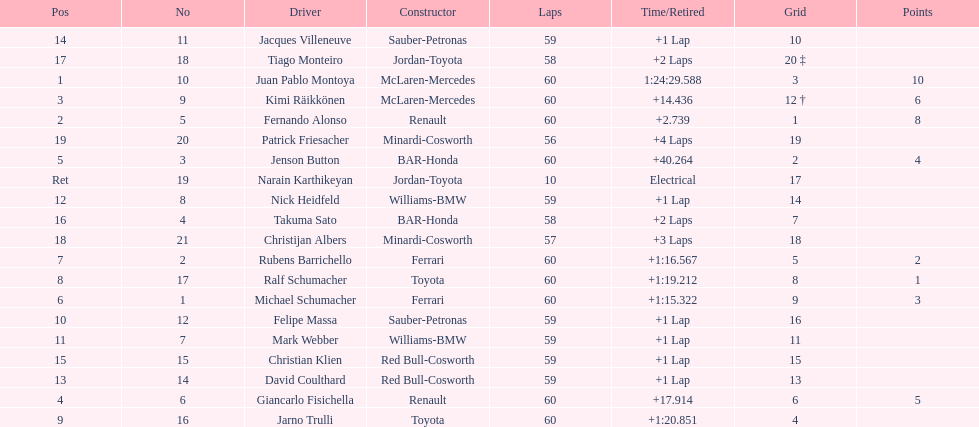How many drivers from germany? 3. 